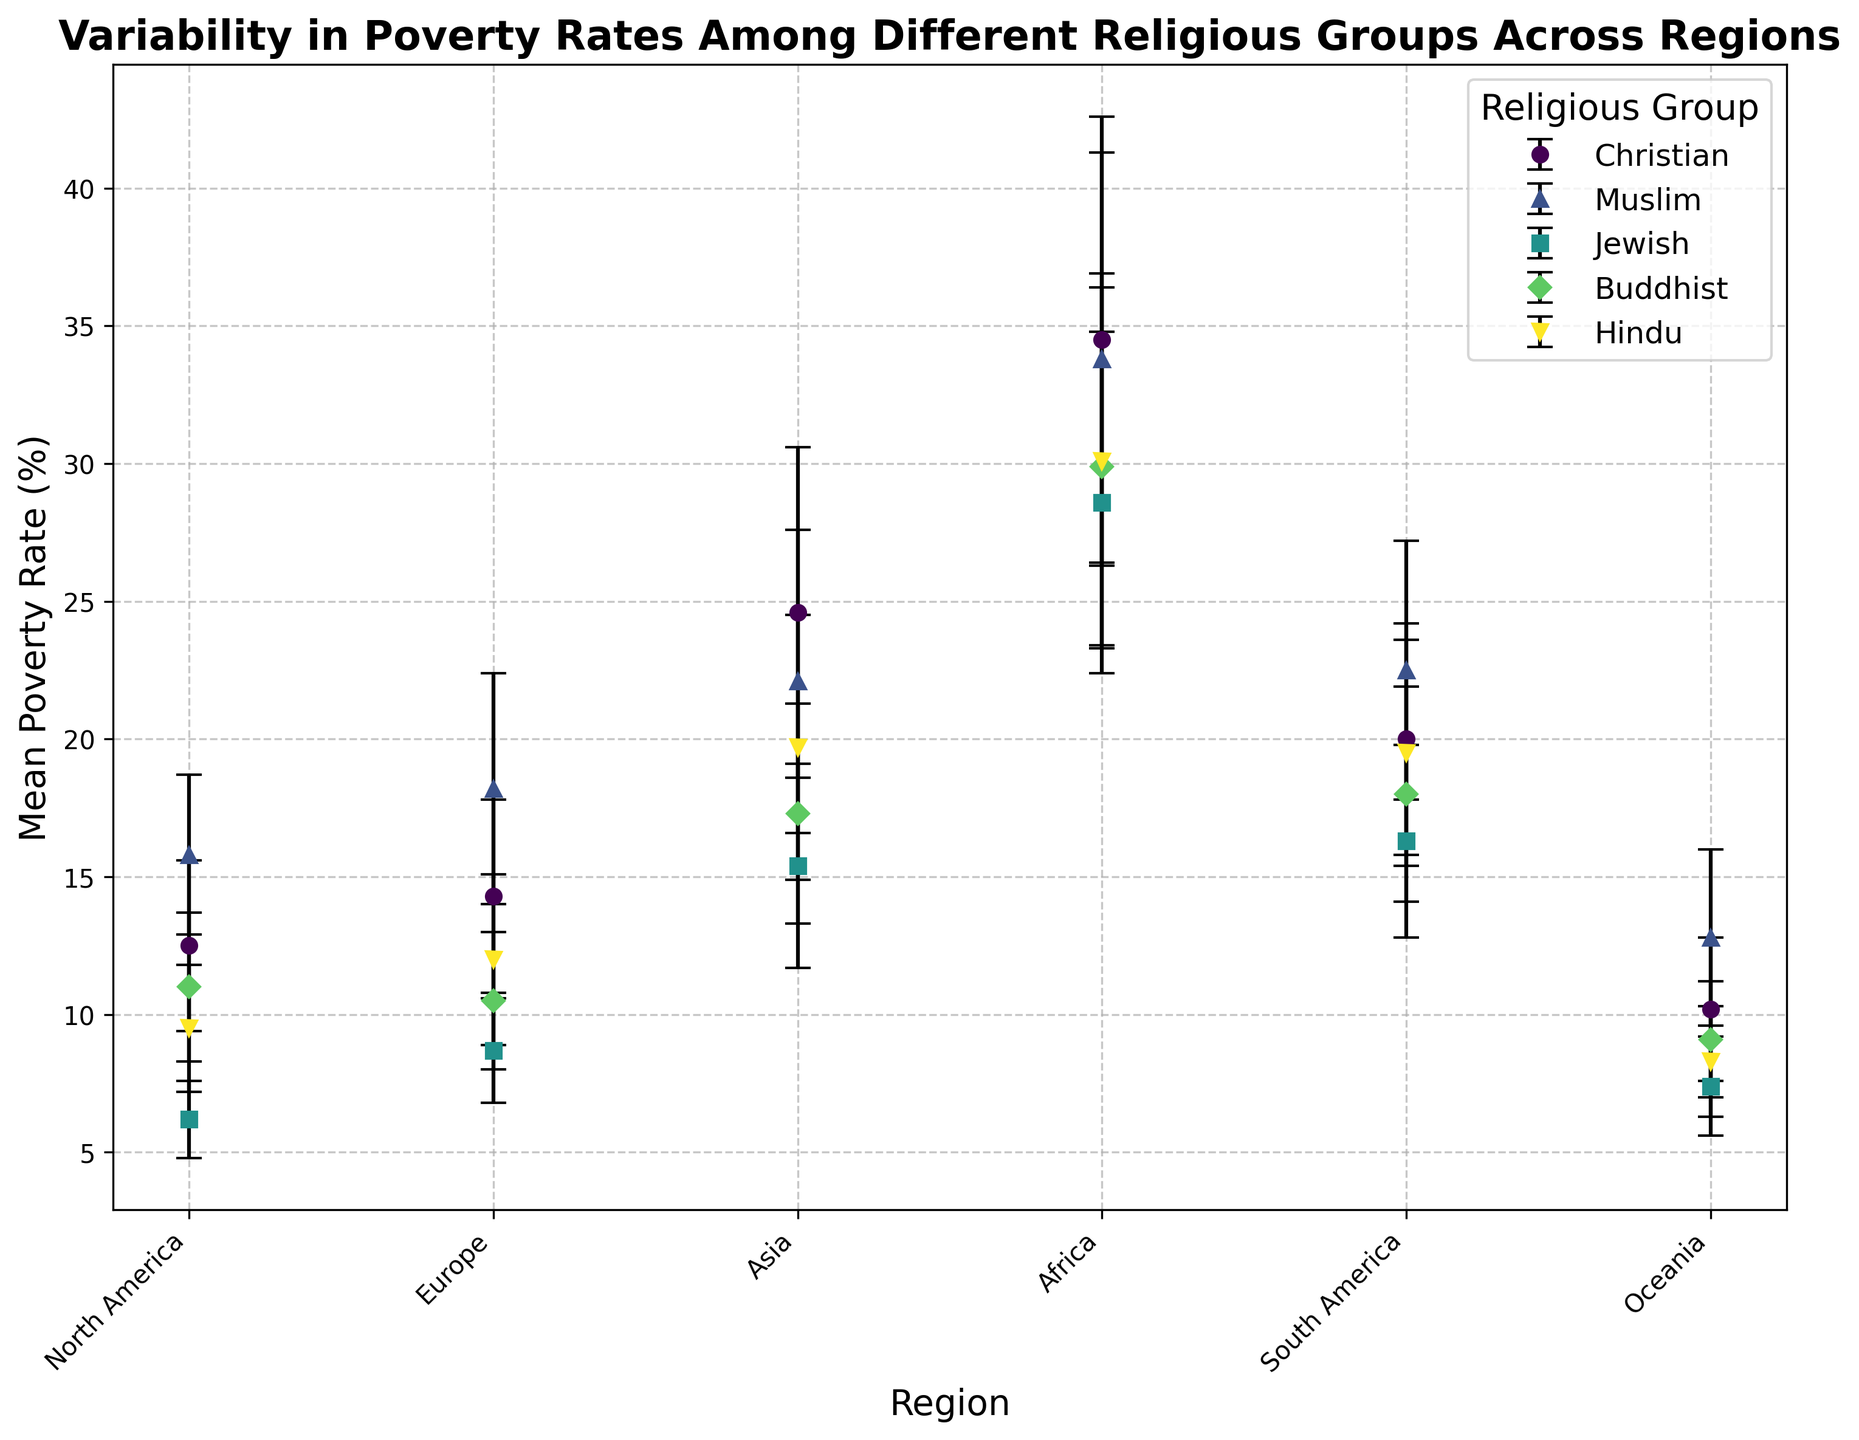Which religious group has the highest mean poverty rate in Africa? To find the group with the highest mean poverty rate in Africa, look at the mean poverty rates for each religious group in the Africa region. Compare these rates to determine the highest one.
Answer: Christian (34.5%) Which region has the lowest mean poverty rate for the Jewish group? To determine the region with the lowest mean poverty rate for the Jewish group, compare the mean poverty rates of the Jewish group across all regions. Identify the region with the smallest value.
Answer: North America (6.2%) What's the difference in mean poverty rates between Muslims and Christians in Europe? Look at the mean poverty rates for Muslims and Christians in Europe. Subtract the mean poverty rate for Christians from that for Muslims to get the difference.
Answer: 18.2 - 14.3 = 3.9 Which region shows the most variability in poverty rates for Buddhists? Compare the standard deviations of poverty rates for Buddhists across all regions. The region with the highest standard deviation indicates the most variability.
Answer: Africa (6.5) What is the average mean poverty rate for Hindus across all regions? Add the mean poverty rates for Hindus in all regions and divide by the number of regions to find the average. Calculation: (9.5 + 12.0 + 19.7 + 30.1 + 19.5 + 8.3) / 6
Answer: (9.5 + 12.0 + 19.7 + 30.1 + 19.5 + 8.3) / 6 = 16.52 In which region do Muslims have a higher mean poverty rate than Christians, and by how much? Compare the mean poverty rates of Muslims and Christians in each region. Identify the regions where the Muslim mean poverty rate is higher than the Christian rate, and calculate the differences.
Answer: North America by 3.3 (15.8 - 12.5), Europe by 3.9 (18.2 - 14.3), Asia by -2.5 (22.1 - 24.6), Africa by -0.7 (33.8 - 34.5), South America by 2.5 (22.5 - 20.0), Oceania by 2.6 (12.8 - 10.2) 